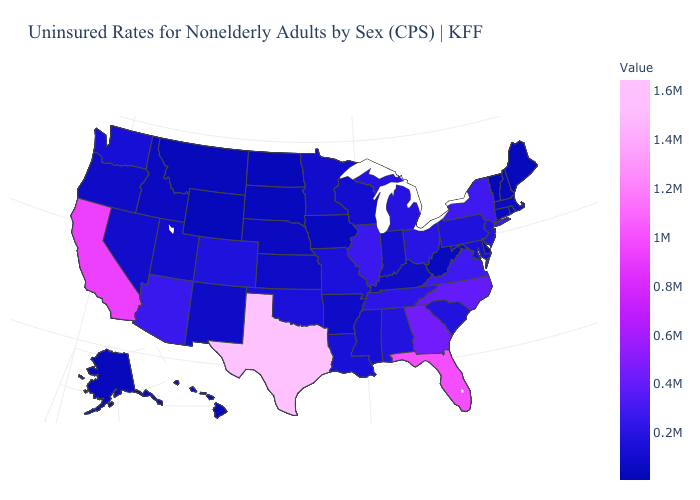Among the states that border New Jersey , does Pennsylvania have the lowest value?
Keep it brief. No. Does New Mexico have a lower value than Illinois?
Give a very brief answer. Yes. Does California have the lowest value in the West?
Be succinct. No. Which states hav the highest value in the MidWest?
Write a very short answer. Illinois. 